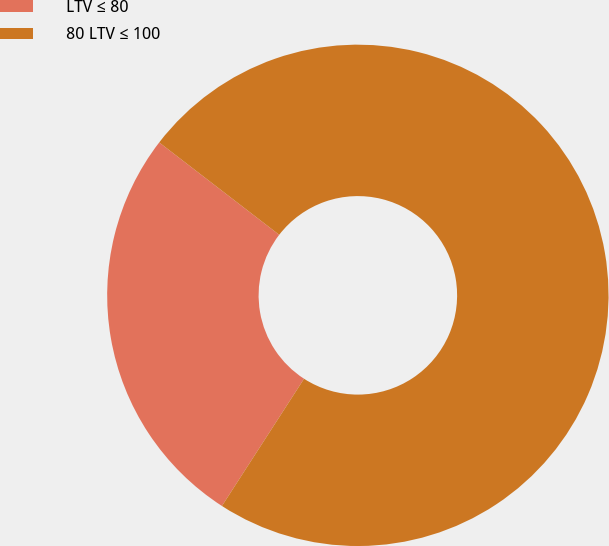Convert chart to OTSL. <chart><loc_0><loc_0><loc_500><loc_500><pie_chart><fcel>LTV ≤ 80<fcel>80 LTV ≤ 100<nl><fcel>26.32%<fcel>73.68%<nl></chart> 